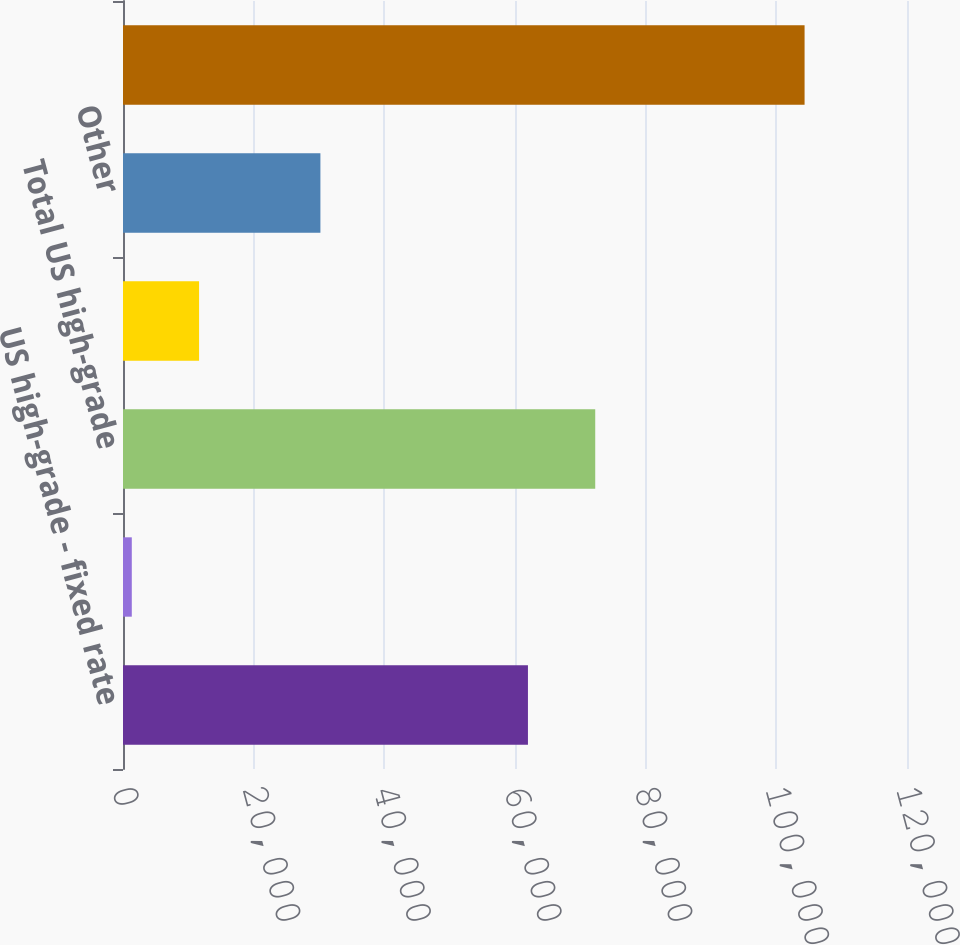Convert chart. <chart><loc_0><loc_0><loc_500><loc_500><bar_chart><fcel>US high-grade - fixed rate<fcel>US high-grade - floating rate<fcel>Total US high-grade<fcel>Eurobond<fcel>Other<fcel>Total<nl><fcel>61982<fcel>1346<fcel>72279.7<fcel>11643.7<fcel>30215<fcel>104323<nl></chart> 